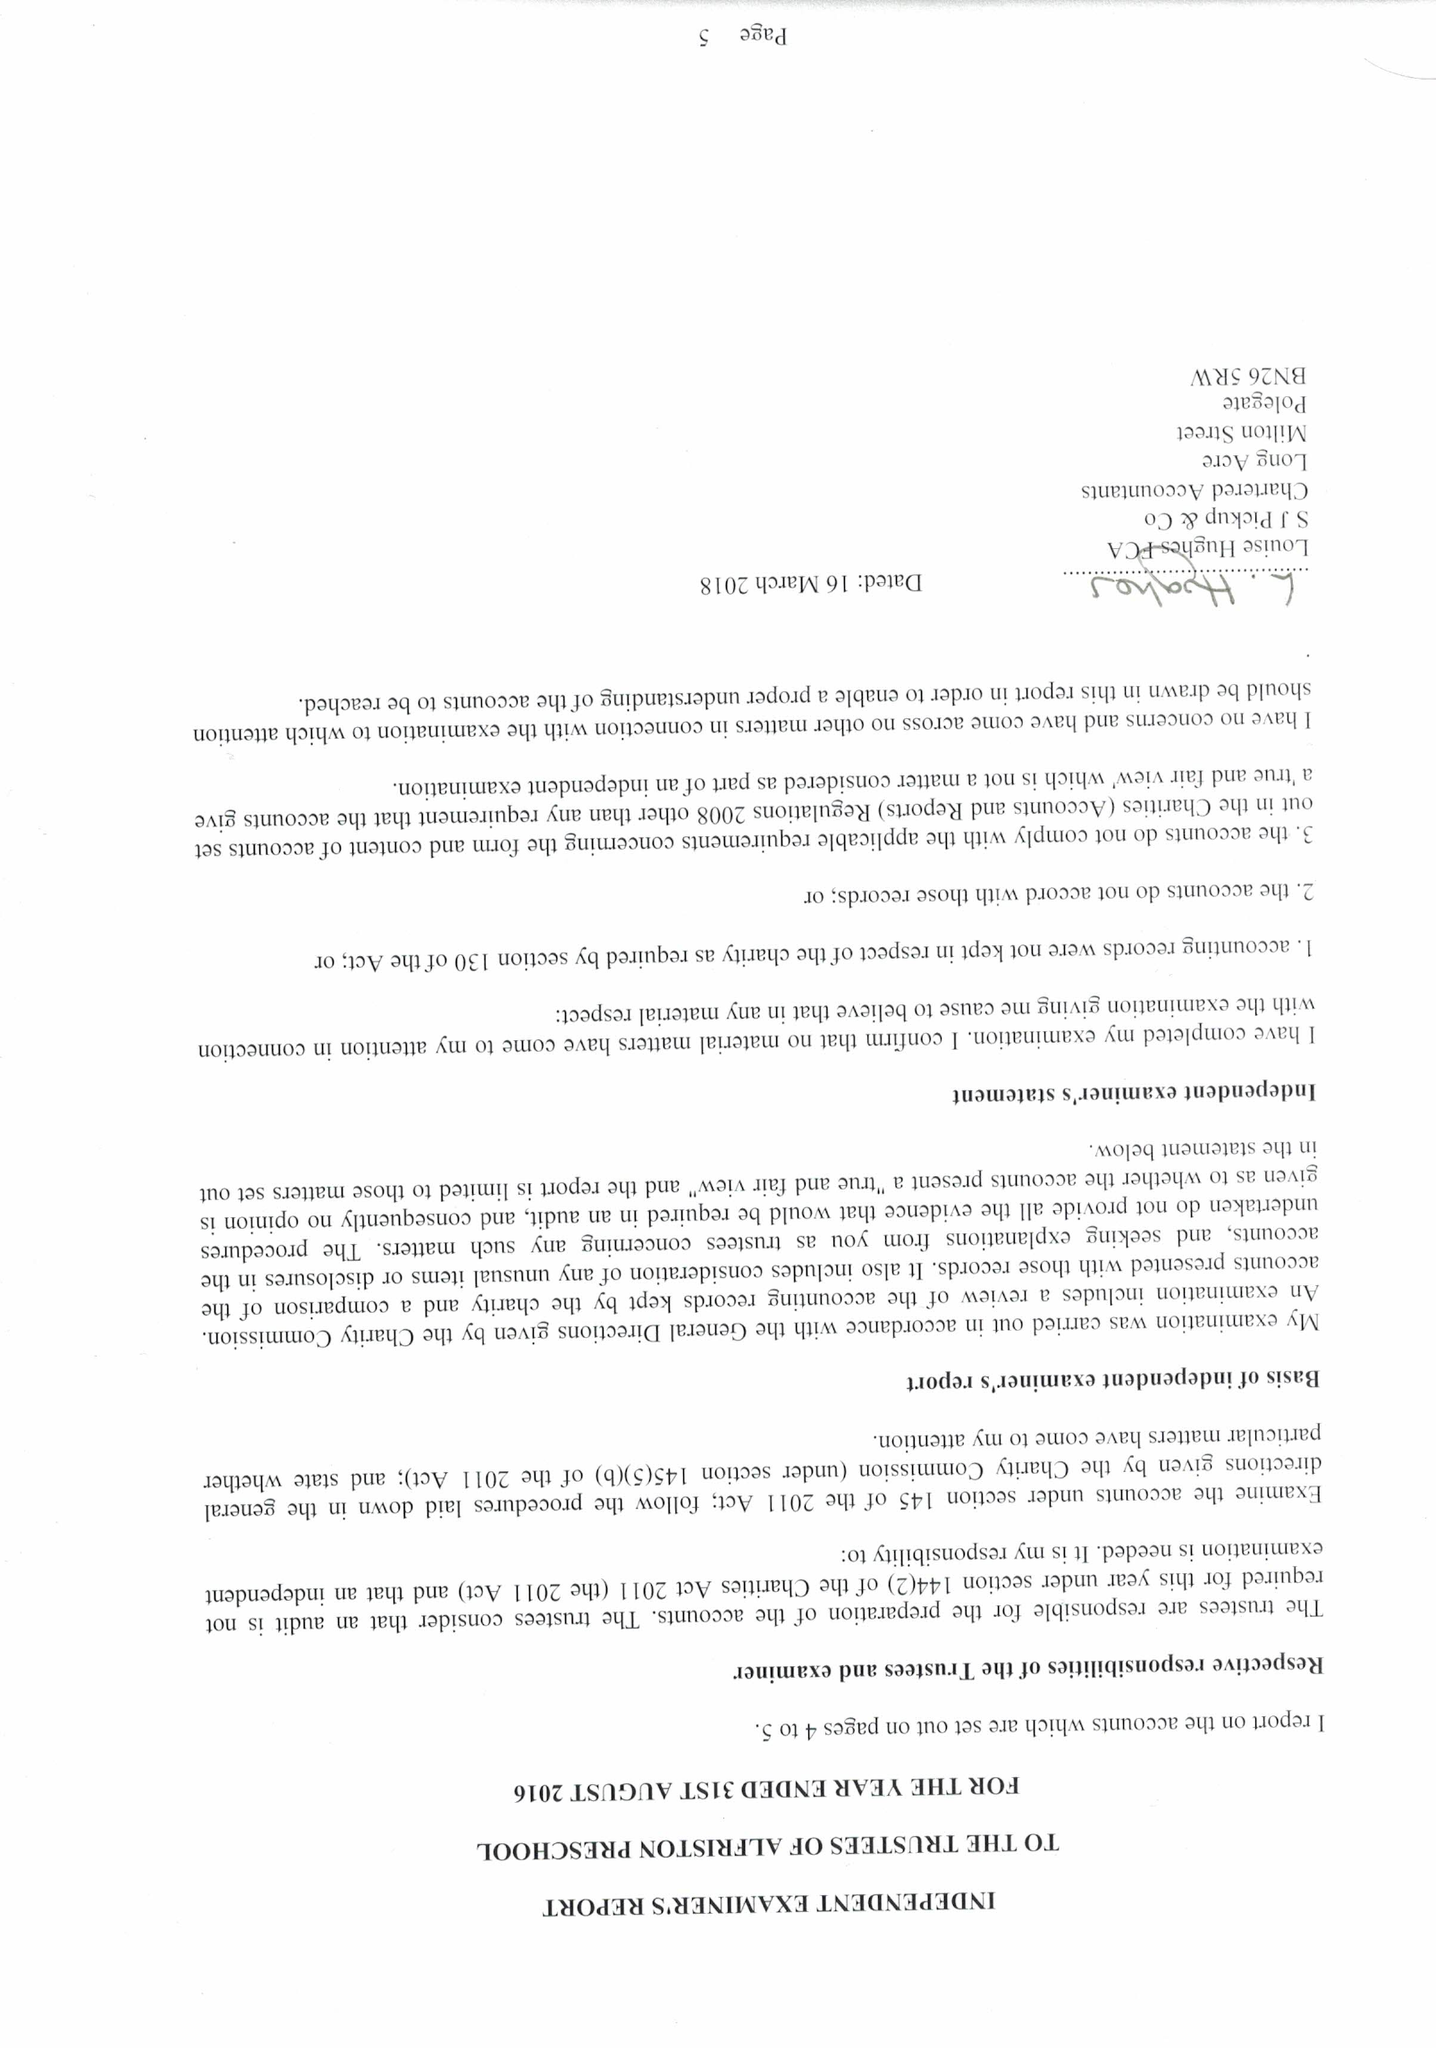What is the value for the charity_number?
Answer the question using a single word or phrase. 1046302 